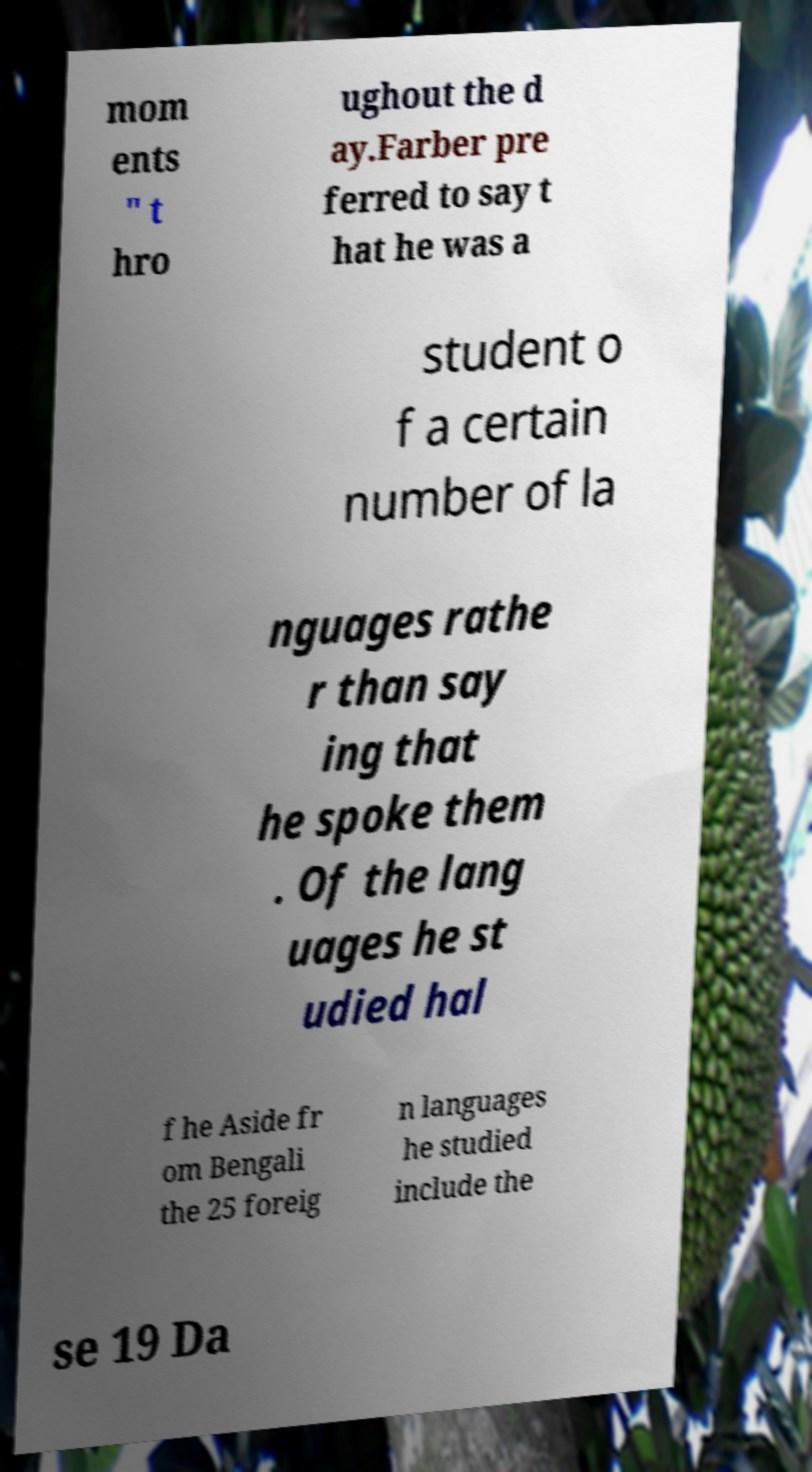Please read and relay the text visible in this image. What does it say? mom ents " t hro ughout the d ay.Farber pre ferred to say t hat he was a student o f a certain number of la nguages rathe r than say ing that he spoke them . Of the lang uages he st udied hal f he Aside fr om Bengali the 25 foreig n languages he studied include the se 19 Da 